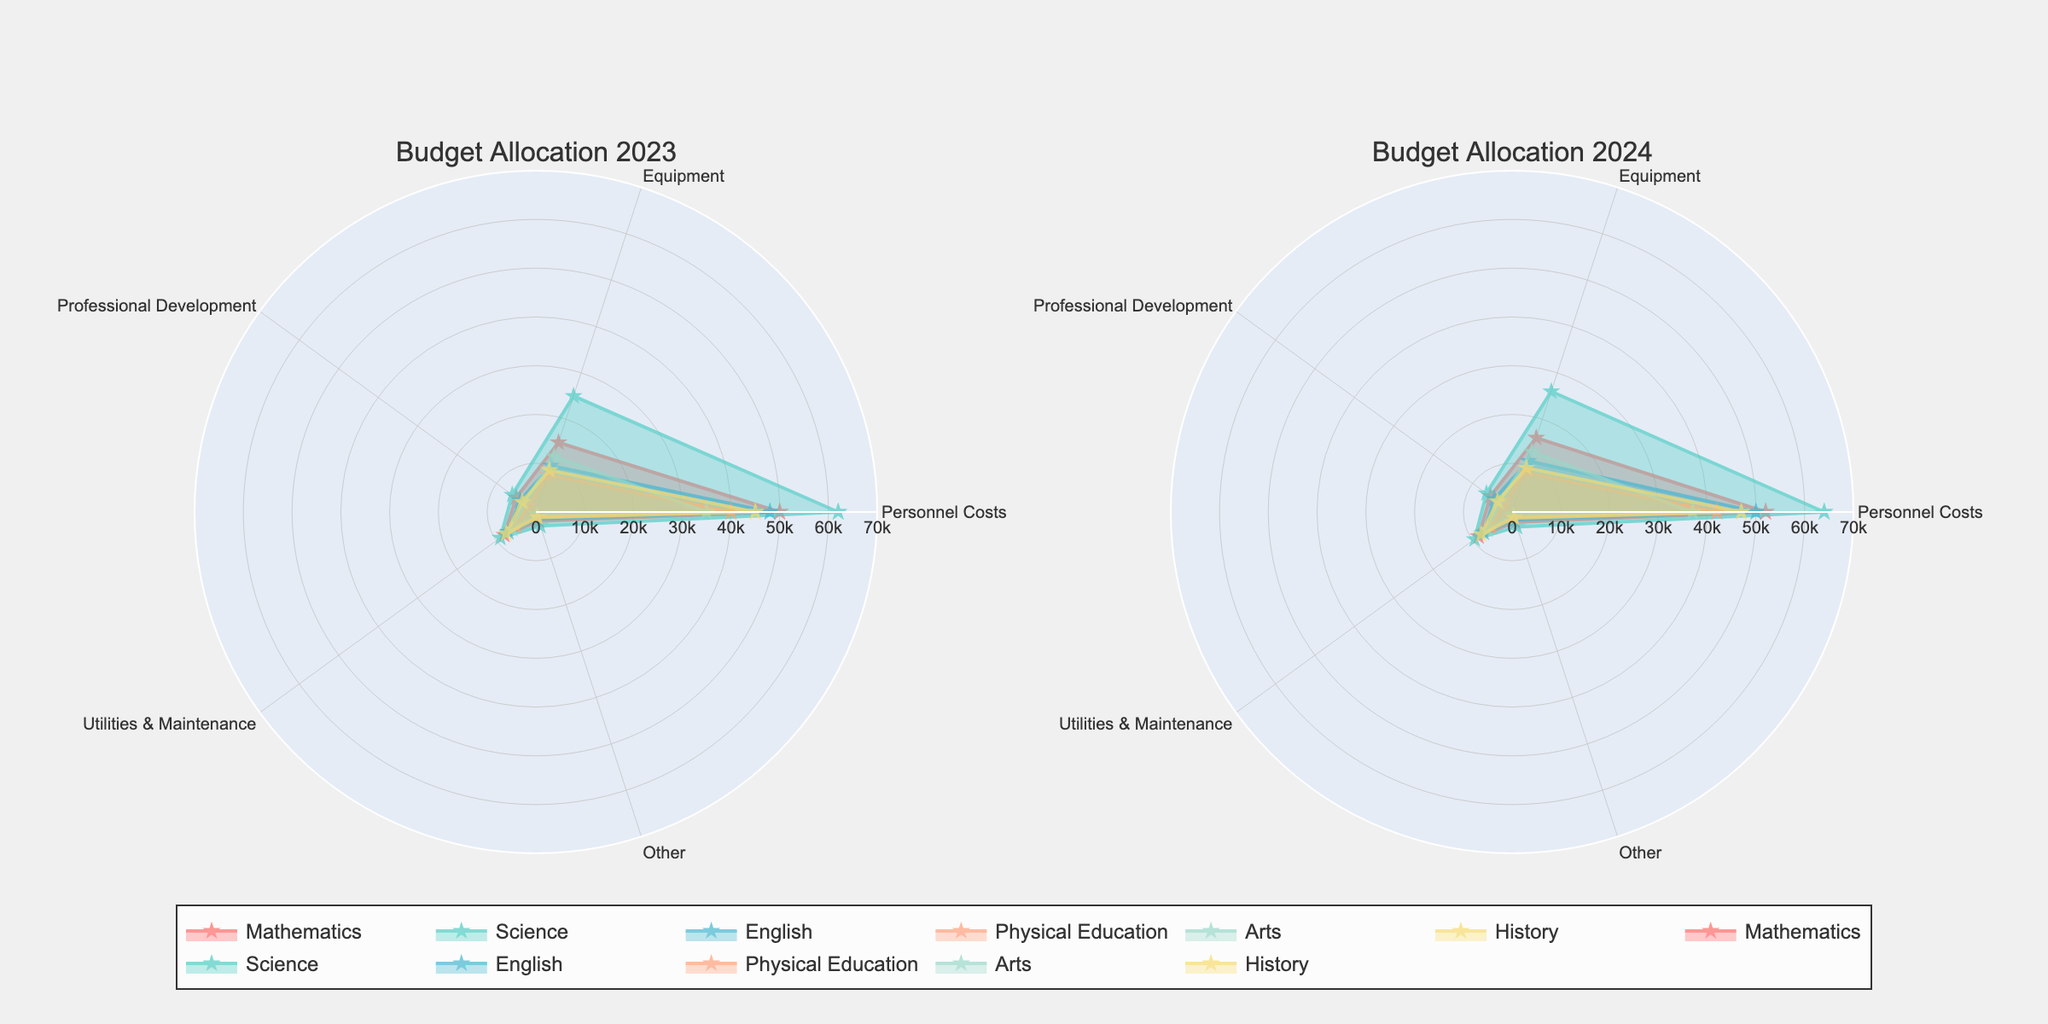Which departments are represented in the radar chart for the year 2023? Look at the labels within the radar chart for the year 2023 to see the names of the departments.
Answer: Mathematics, Science, English, Physical Education, Arts, History What color represents the Science department in the radar charts? Identify the color of the lines and fill area for Science by looking at the legend in the chart.
Answer: Aqua Which department has the highest Personnel Costs in 2024? Compare the radial length for the Personnel Costs category for each department in the 2024 chart.
Answer: Science How do the Equipment expenses for the Mathematics department compare between 2023 and 2024? Compare the values plotted for Equipment in 2023 and 2024 for the Mathematics department.
Answer: Higher in 2024 Which expense category does the Arts department spend the least on in 2023? Identify the smallest radial length among the categories for the Arts department in 2023.
Answer: Other How does the total expenditure on Equipment across all departments change from 2023 to 2024? Sum up the Equipment values for all departments for both years and compare the totals.
Answer: Increase Which department saw the most significant increase in Personnel Costs from 2023 to 2024? Calculate the difference in Personnel Costs for each department between 2023 and 2024 and identify the largest increase.
Answer: Science Are there any departments where the Utility & Maintenance expenses decreased from 2023 to 2024? Compare the Utility & Maintenance expenses for each department between 2023 and 2024.
Answer: No Which category is represented by the largest radial distance in the Science department's 2023 radar chart? Identify the category with the highest radial extent for the Science department in the 2023 chart.
Answer: Personnel Costs What is the average Personnel Costs for all departments in 2024? Sum the Personnel Costs for all departments in 2024 and divide by the number of departments (6).
Answer: 49,833.33 